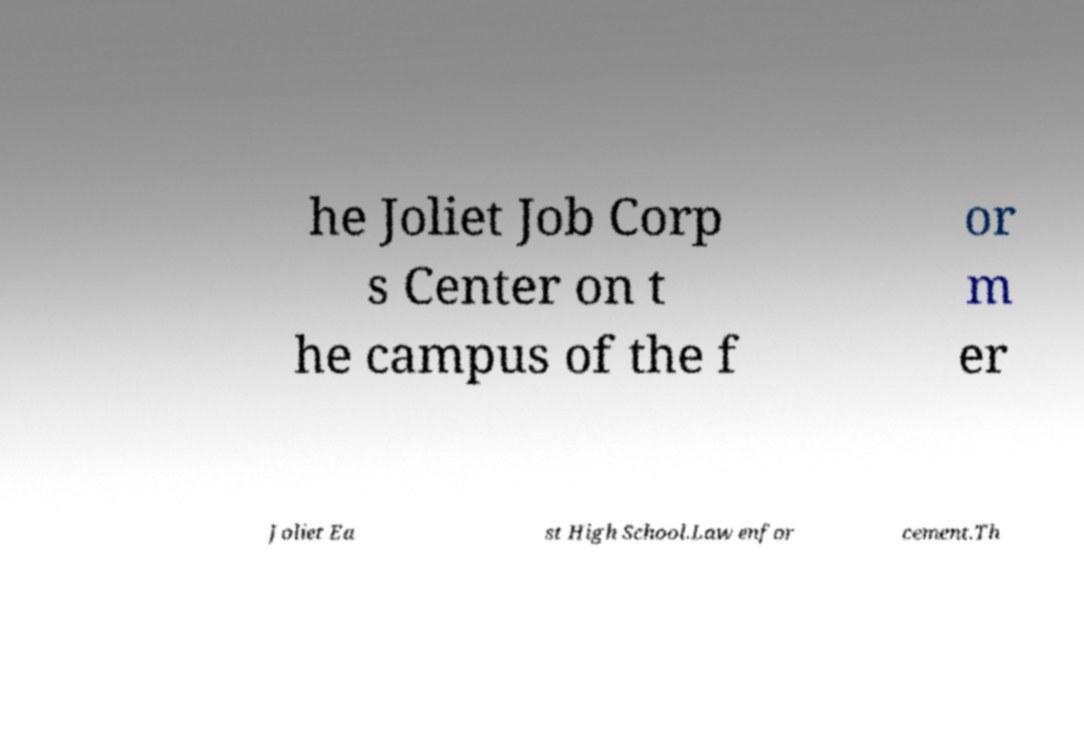I need the written content from this picture converted into text. Can you do that? he Joliet Job Corp s Center on t he campus of the f or m er Joliet Ea st High School.Law enfor cement.Th 